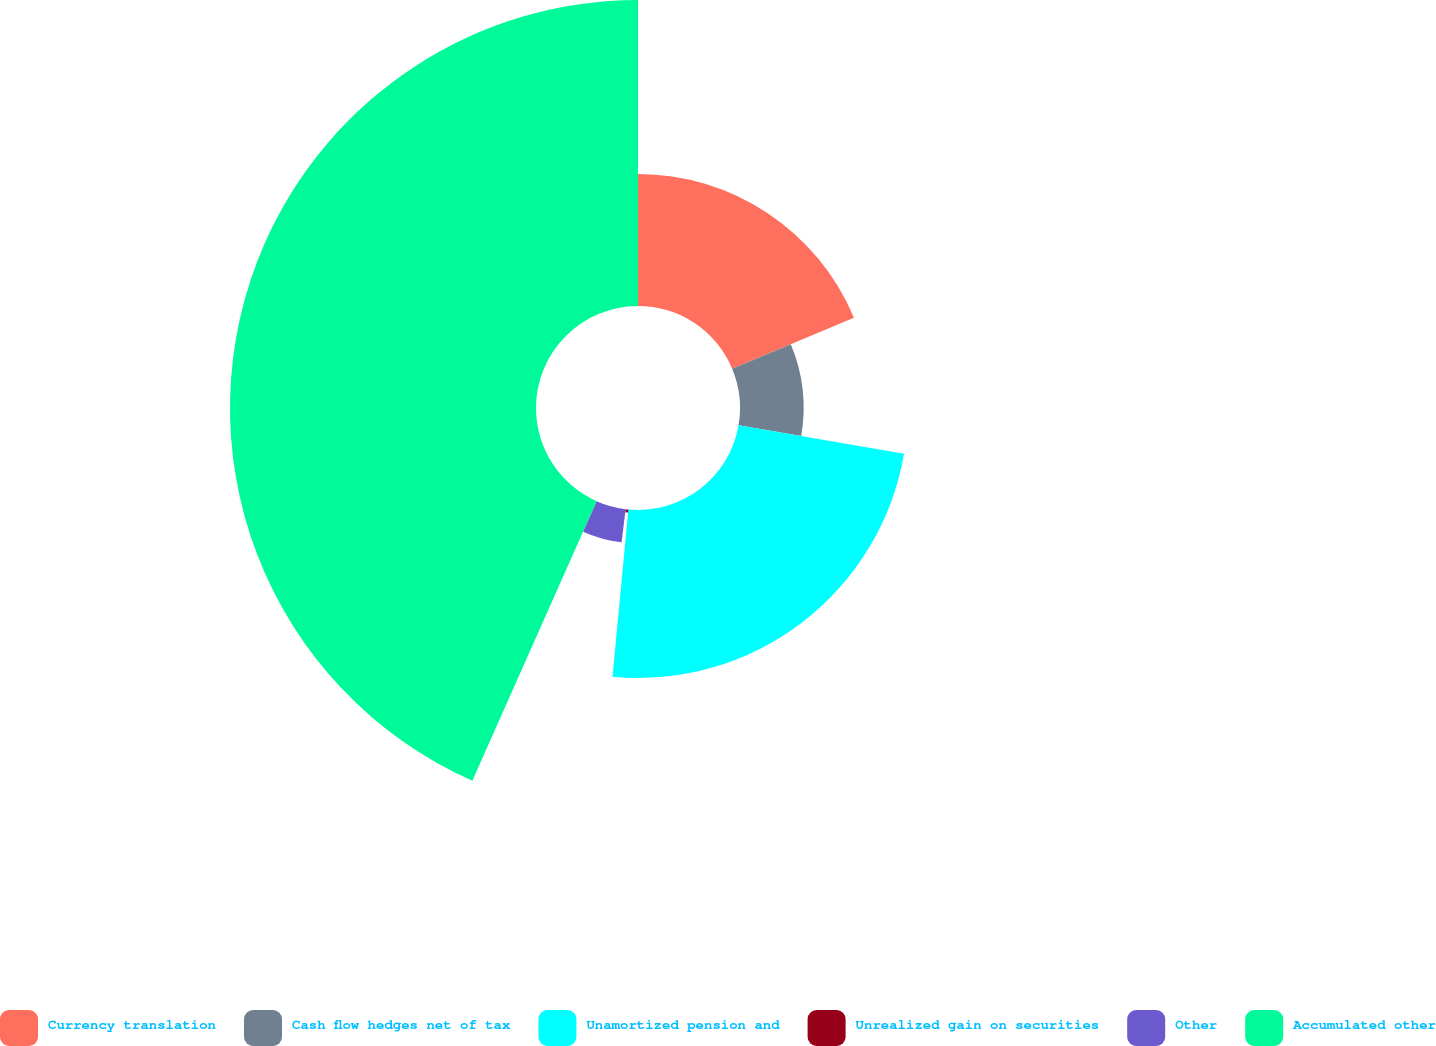<chart> <loc_0><loc_0><loc_500><loc_500><pie_chart><fcel>Currency translation<fcel>Cash flow hedges net of tax<fcel>Unamortized pension and<fcel>Unrealized gain on securities<fcel>Other<fcel>Accumulated other<nl><fcel>18.7%<fcel>9.01%<fcel>23.79%<fcel>0.43%<fcel>4.72%<fcel>43.34%<nl></chart> 